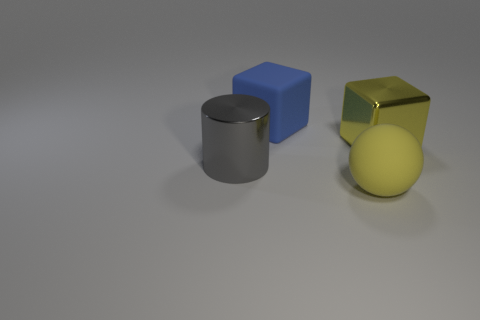Add 3 red things. How many objects exist? 7 Subtract all balls. How many objects are left? 3 Add 4 big brown metal cylinders. How many big brown metal cylinders exist? 4 Subtract 0 cyan cubes. How many objects are left? 4 Subtract all small purple metallic cubes. Subtract all large gray shiny cylinders. How many objects are left? 3 Add 3 big yellow spheres. How many big yellow spheres are left? 4 